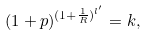Convert formula to latex. <formula><loc_0><loc_0><loc_500><loc_500>( 1 + p ) ^ { ( 1 + \frac { 1 } { R } ) ^ { l ^ { \prime } } } = k ,</formula> 